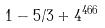<formula> <loc_0><loc_0><loc_500><loc_500>1 - 5 / 3 + 4 ^ { 4 6 6 }</formula> 